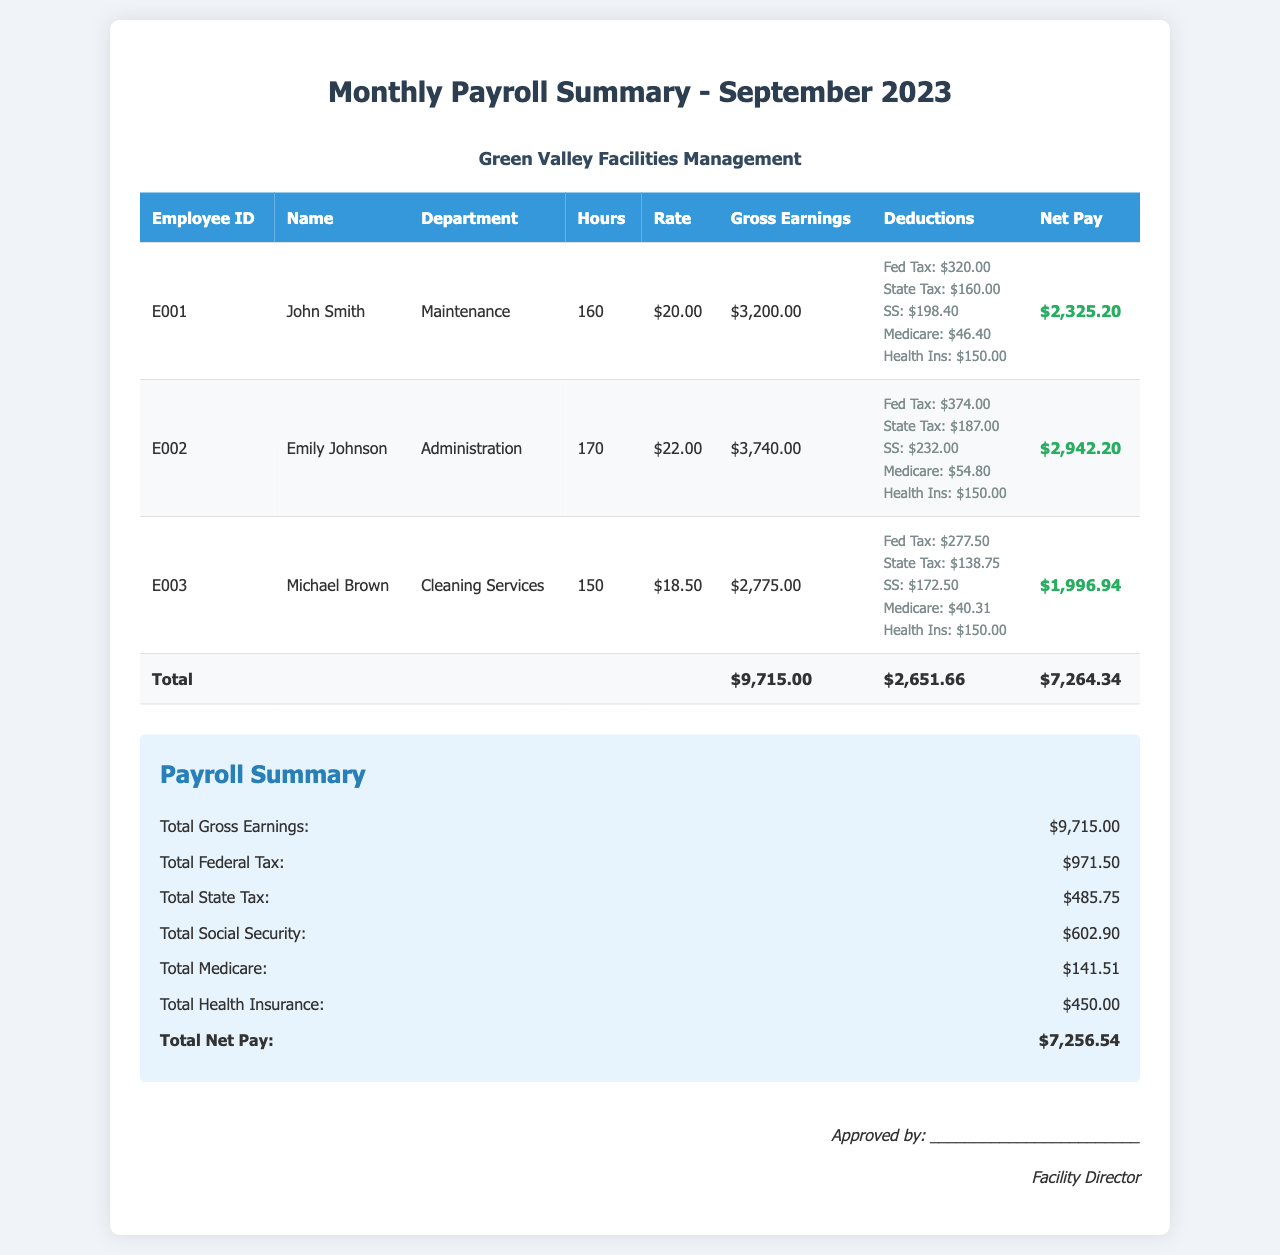What is the total gross earnings for September 2023? The total gross earnings are calculated by summing all employees' gross earnings listed in the table, which amounts to $3,200.00 + $3,740.00 + $2,775.00 = $9,715.00.
Answer: $9,715.00 Who is the employee with the highest net pay? The net pay for each employee is provided in the last column of the table, and Emily Johnson has the highest net pay of $2,942.20.
Answer: Emily Johnson How many hours did Michael Brown work in September 2023? The number of hours worked by Michael Brown is recorded in the table under the "Hours" column, which shows he worked 150 hours.
Answer: 150 What is the total amount deducted for federal taxes? The total deduction for federal taxes is calculated by adding the federal tax amounts listed for each employee, which is $320.00 + $374.00 + $277.50 = $971.50.
Answer: $971.50 What department does John Smith belong to? John Smith's department is specified in the table, where it shows he works in the Maintenance department.
Answer: Maintenance What is the total net pay for all employees combined? The total net pay for all employees is the sum of their individual net pays listed in the last column, which adds up to $2,325.20 + $2,942.20 + $1,996.94 = $7,264.34.
Answer: $7,264.34 Which deduction has the highest amount for Emily Johnson? To find this, we look at the deduction details for Emily Johnson and see that the highest individual deduction is the Federal Tax at $374.00.
Answer: Fed Tax: $374.00 What is the signature title at the bottom of the document? The document specifies the title of the signatory at the bottom as "Facility Director."
Answer: Facility Director 